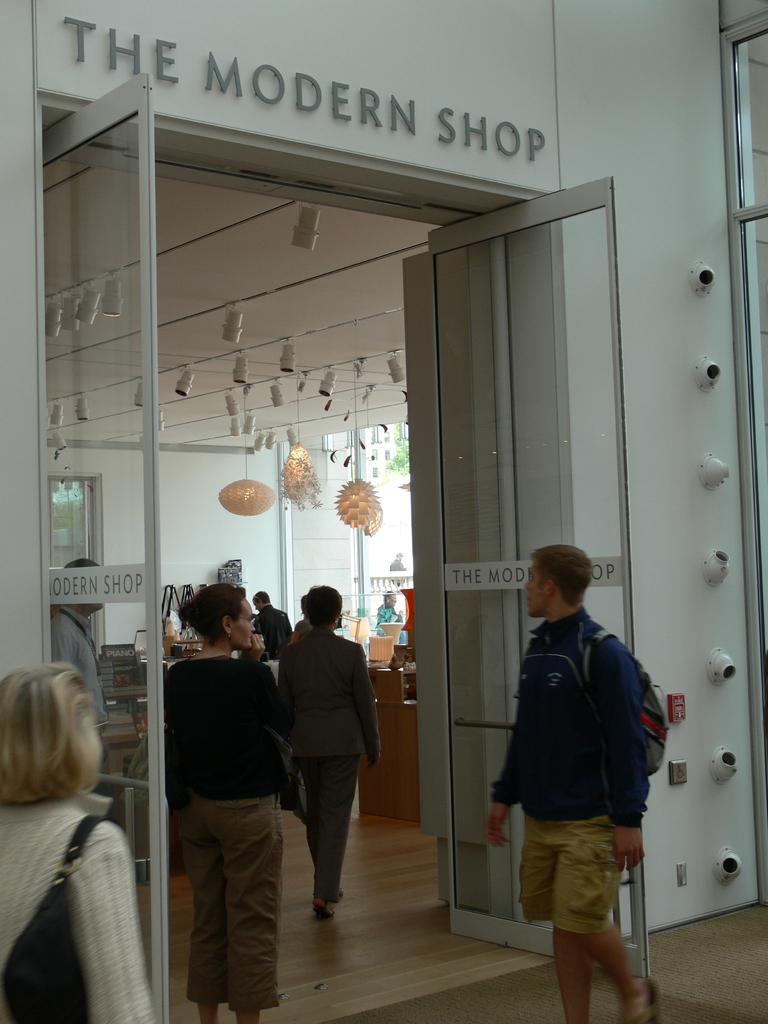How would you summarize this image in a sentence or two? In this image we can see a store and there are people. In the background there are decors, doors and walls. 